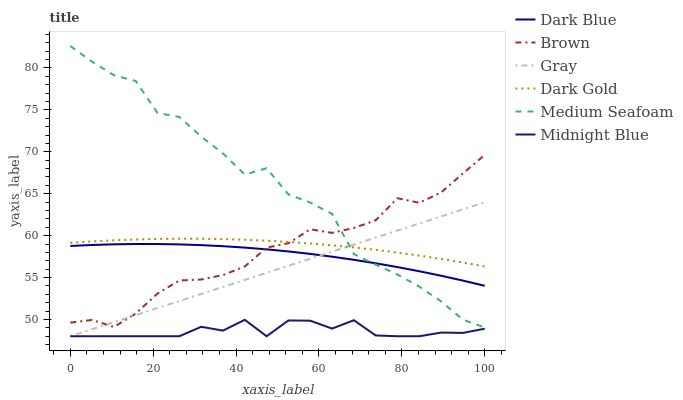Does Midnight Blue have the minimum area under the curve?
Answer yes or no. Yes. Does Medium Seafoam have the maximum area under the curve?
Answer yes or no. Yes. Does Brown have the minimum area under the curve?
Answer yes or no. No. Does Brown have the maximum area under the curve?
Answer yes or no. No. Is Gray the smoothest?
Answer yes or no. Yes. Is Medium Seafoam the roughest?
Answer yes or no. Yes. Is Midnight Blue the smoothest?
Answer yes or no. No. Is Midnight Blue the roughest?
Answer yes or no. No. Does Gray have the lowest value?
Answer yes or no. Yes. Does Brown have the lowest value?
Answer yes or no. No. Does Medium Seafoam have the highest value?
Answer yes or no. Yes. Does Brown have the highest value?
Answer yes or no. No. Is Midnight Blue less than Dark Blue?
Answer yes or no. Yes. Is Dark Blue greater than Midnight Blue?
Answer yes or no. Yes. Does Brown intersect Dark Gold?
Answer yes or no. Yes. Is Brown less than Dark Gold?
Answer yes or no. No. Is Brown greater than Dark Gold?
Answer yes or no. No. Does Midnight Blue intersect Dark Blue?
Answer yes or no. No. 